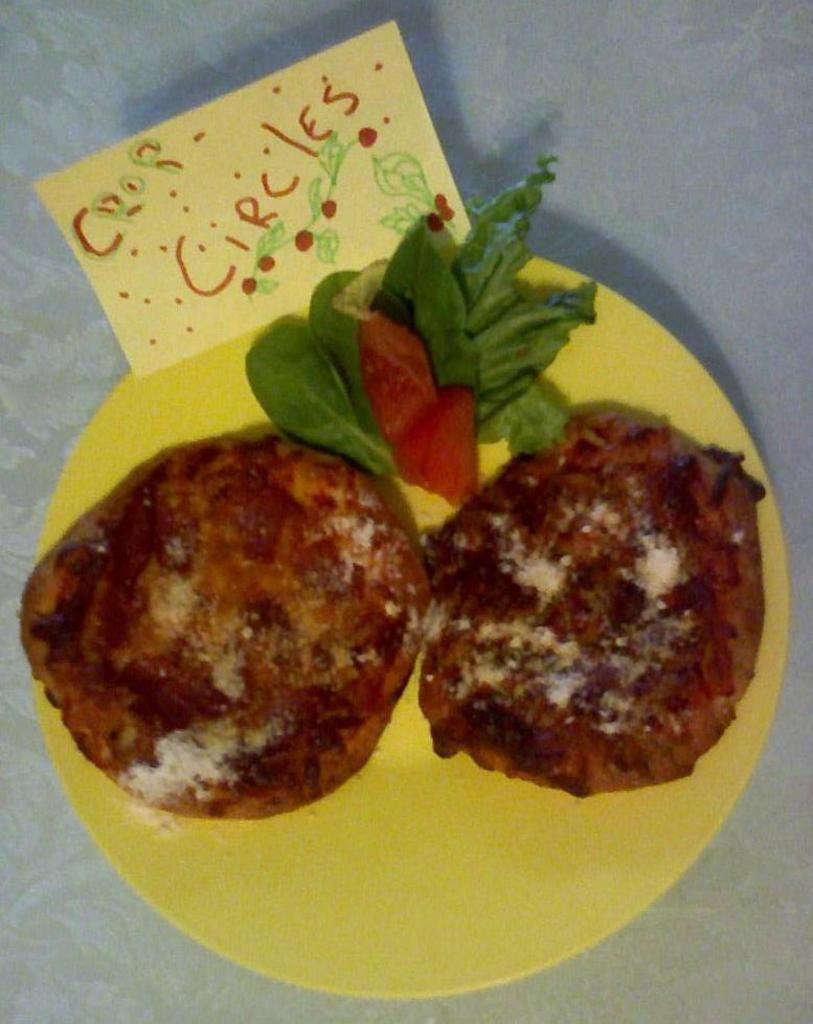What is the main subject of the image? There is a food item in the image. How is the food item presented? The food item is on a plate. Are there any words or phrases in the image? Yes, there is some text in the image. How many men are talking in the image? There are no men or talking depicted in the image; it features a food item on a plate and some text. 